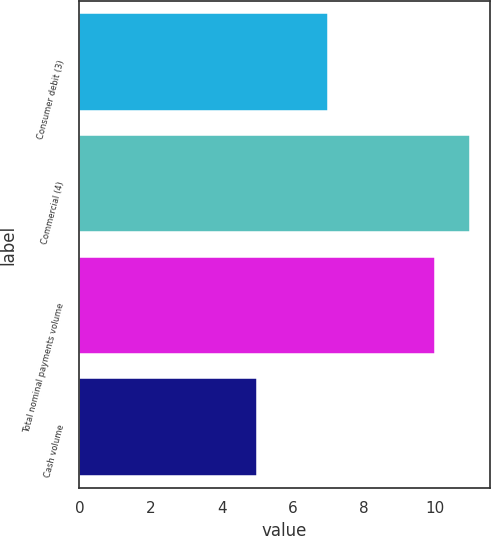<chart> <loc_0><loc_0><loc_500><loc_500><bar_chart><fcel>Consumer debit (3)<fcel>Commercial (4)<fcel>Total nominal payments volume<fcel>Cash volume<nl><fcel>7<fcel>11<fcel>10<fcel>5<nl></chart> 